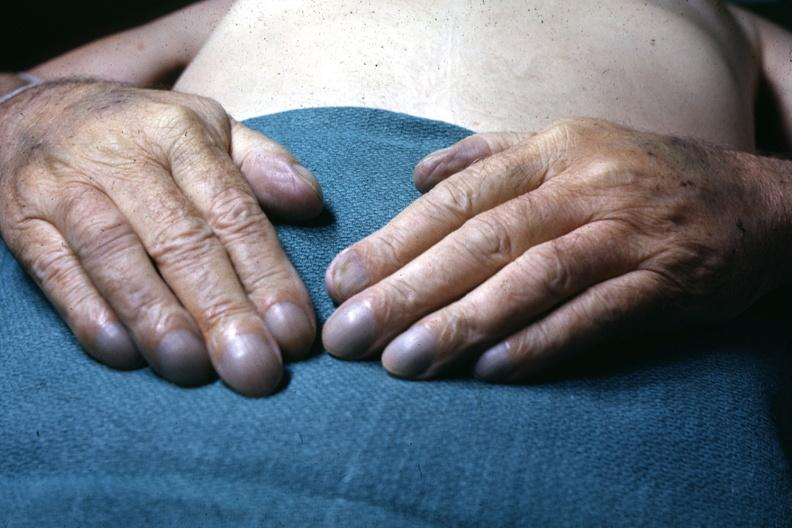what does this image show?
Answer the question using a single word or phrase. Excellent example of pulmonary osteoarthropathy 